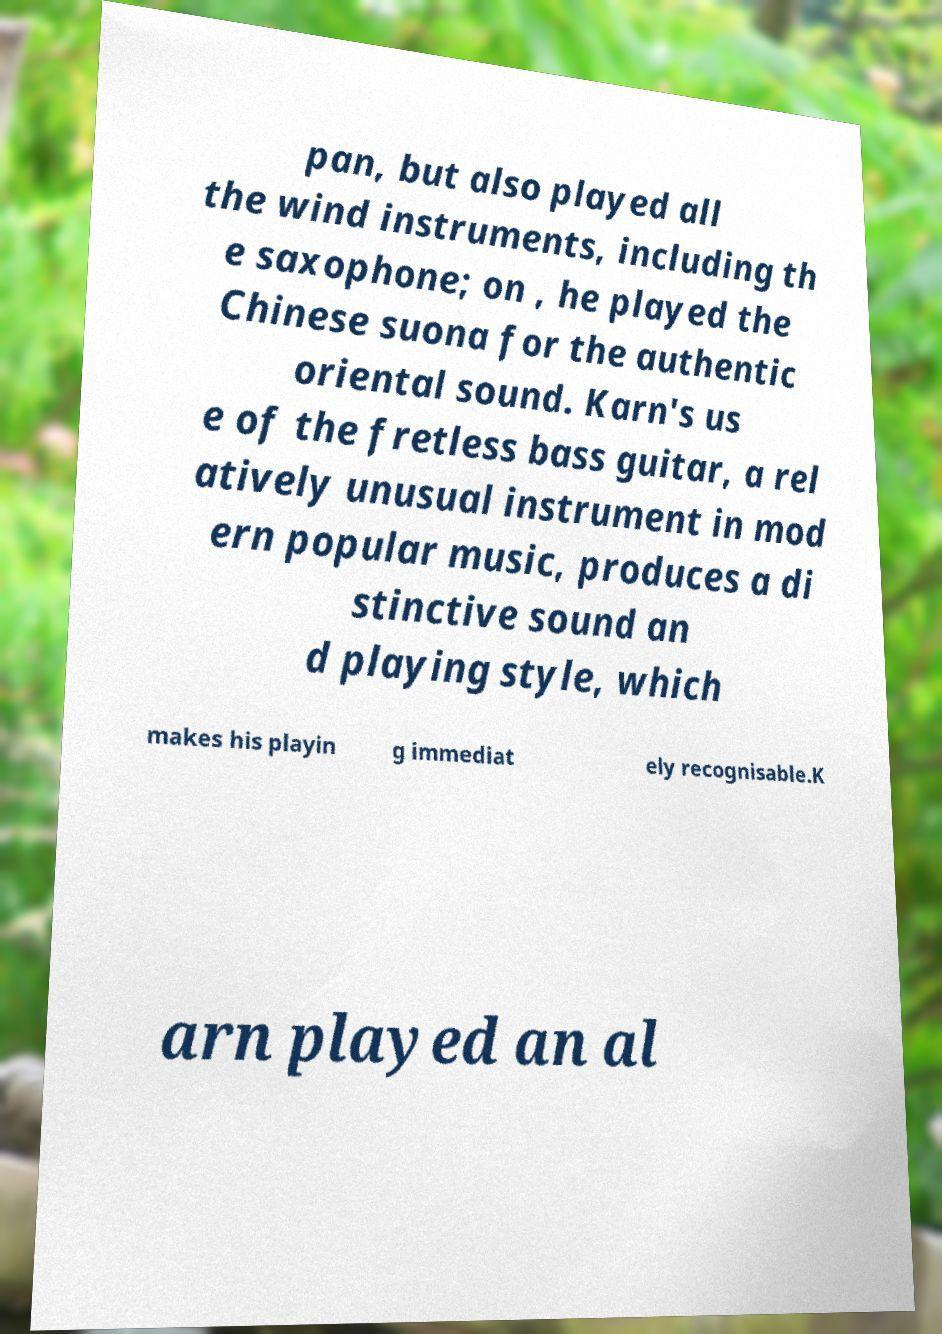Can you read and provide the text displayed in the image?This photo seems to have some interesting text. Can you extract and type it out for me? pan, but also played all the wind instruments, including th e saxophone; on , he played the Chinese suona for the authentic oriental sound. Karn's us e of the fretless bass guitar, a rel atively unusual instrument in mod ern popular music, produces a di stinctive sound an d playing style, which makes his playin g immediat ely recognisable.K arn played an al 